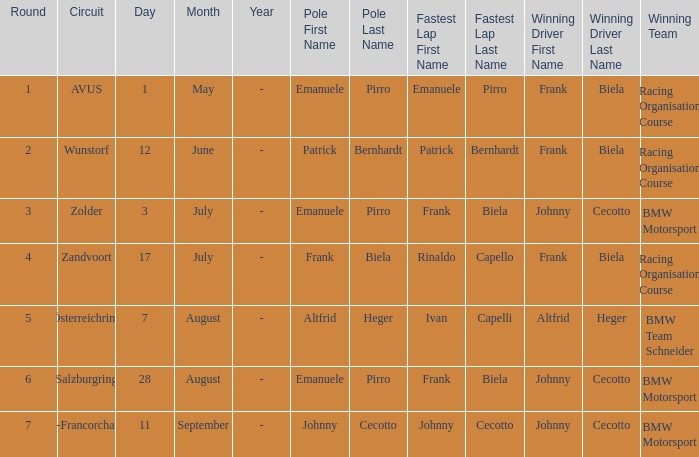What round was circuit Avus? 1.0. 